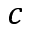<formula> <loc_0><loc_0><loc_500><loc_500>c</formula> 